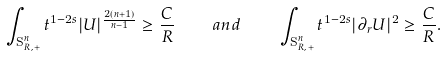<formula> <loc_0><loc_0><loc_500><loc_500>\int _ { \mathbf S ^ { n } _ { R , + } } t ^ { 1 - 2 s } | U | ^ { \frac { 2 ( n + 1 ) } { n - 1 } } \geq \frac { C } { R } \quad a n d \quad \int _ { \mathbf S ^ { n } _ { R , + } } t ^ { 1 - 2 s } | \partial _ { r } U | ^ { 2 } \geq \frac { C } { R } .</formula> 